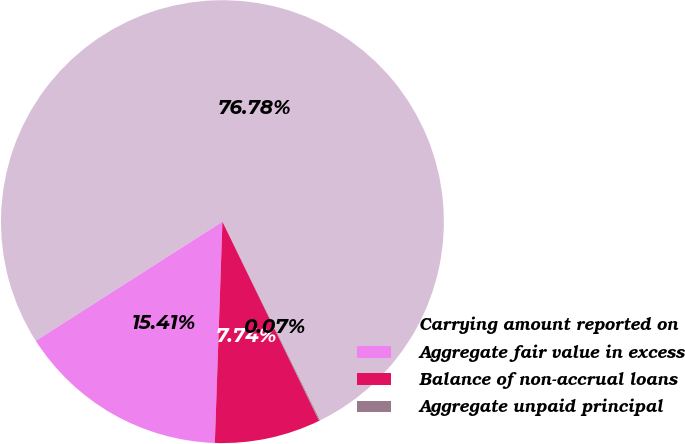Convert chart. <chart><loc_0><loc_0><loc_500><loc_500><pie_chart><fcel>Carrying amount reported on<fcel>Aggregate fair value in excess<fcel>Balance of non-accrual loans<fcel>Aggregate unpaid principal<nl><fcel>76.78%<fcel>15.41%<fcel>7.74%<fcel>0.07%<nl></chart> 